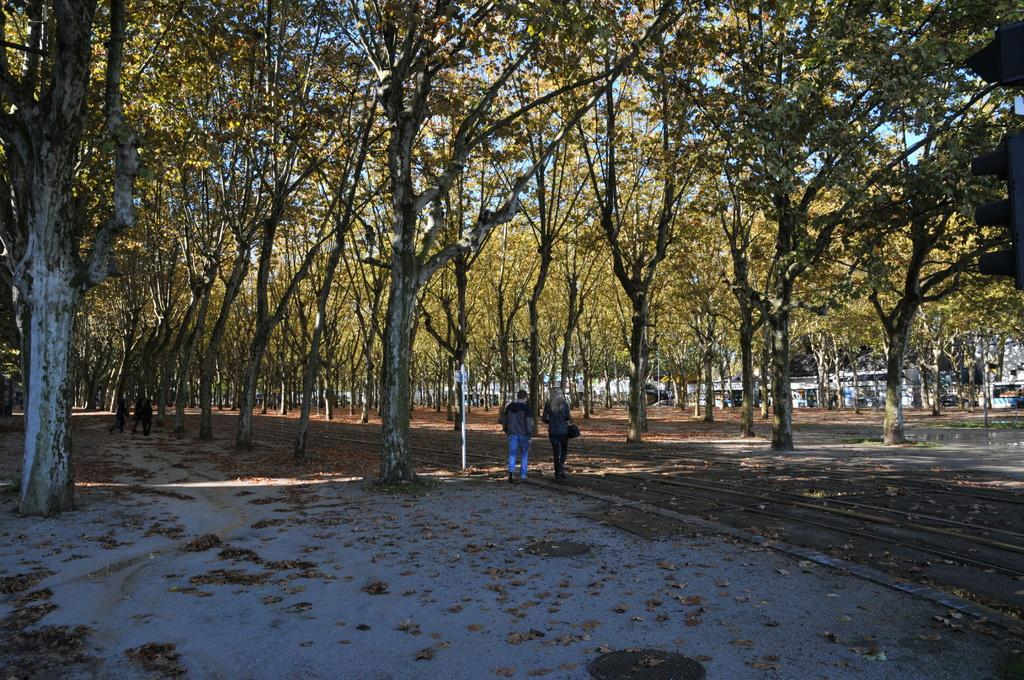What type of natural elements can be seen in the image? There are trees in the image. What else is present in the image besides trees? There are people, houses, and other objects in the image. Can you describe the background of the image? The sky is visible in the background of the image. What is visible at the bottom of the image? The floor is visible at the bottom of the image. How many sisters are present in the image? There is no mention of sisters in the image, so we cannot determine the number of sisters present. What type of wood is used to construct the houses in the image? There is no information about the construction materials of the houses in the image, so we cannot determine the type of wood used. 